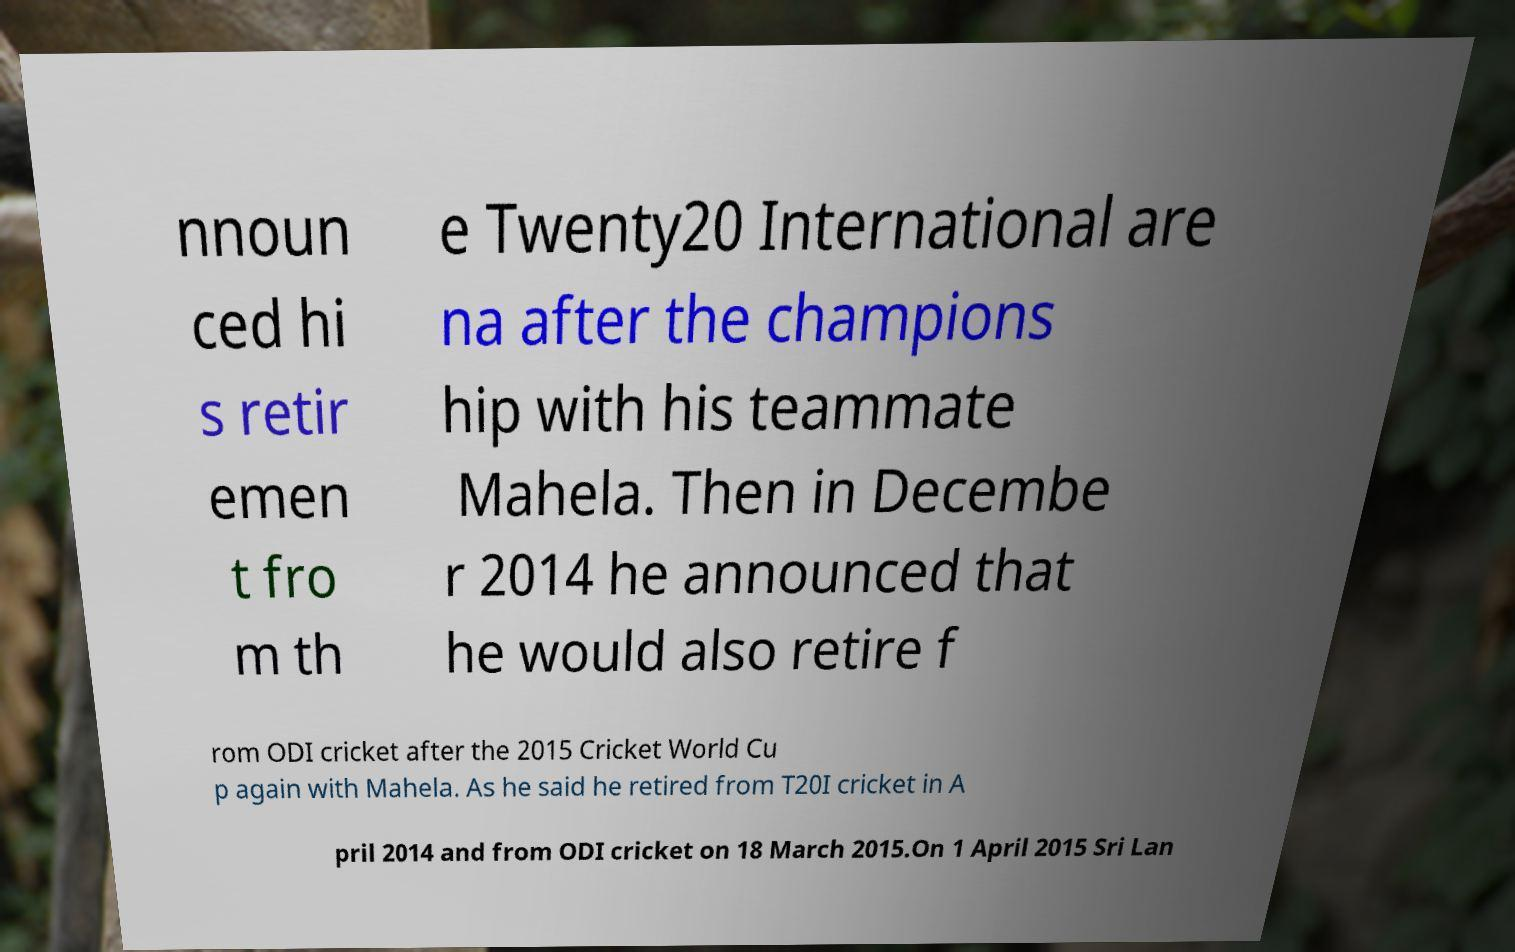Please read and relay the text visible in this image. What does it say? nnoun ced hi s retir emen t fro m th e Twenty20 International are na after the champions hip with his teammate Mahela. Then in Decembe r 2014 he announced that he would also retire f rom ODI cricket after the 2015 Cricket World Cu p again with Mahela. As he said he retired from T20I cricket in A pril 2014 and from ODI cricket on 18 March 2015.On 1 April 2015 Sri Lan 